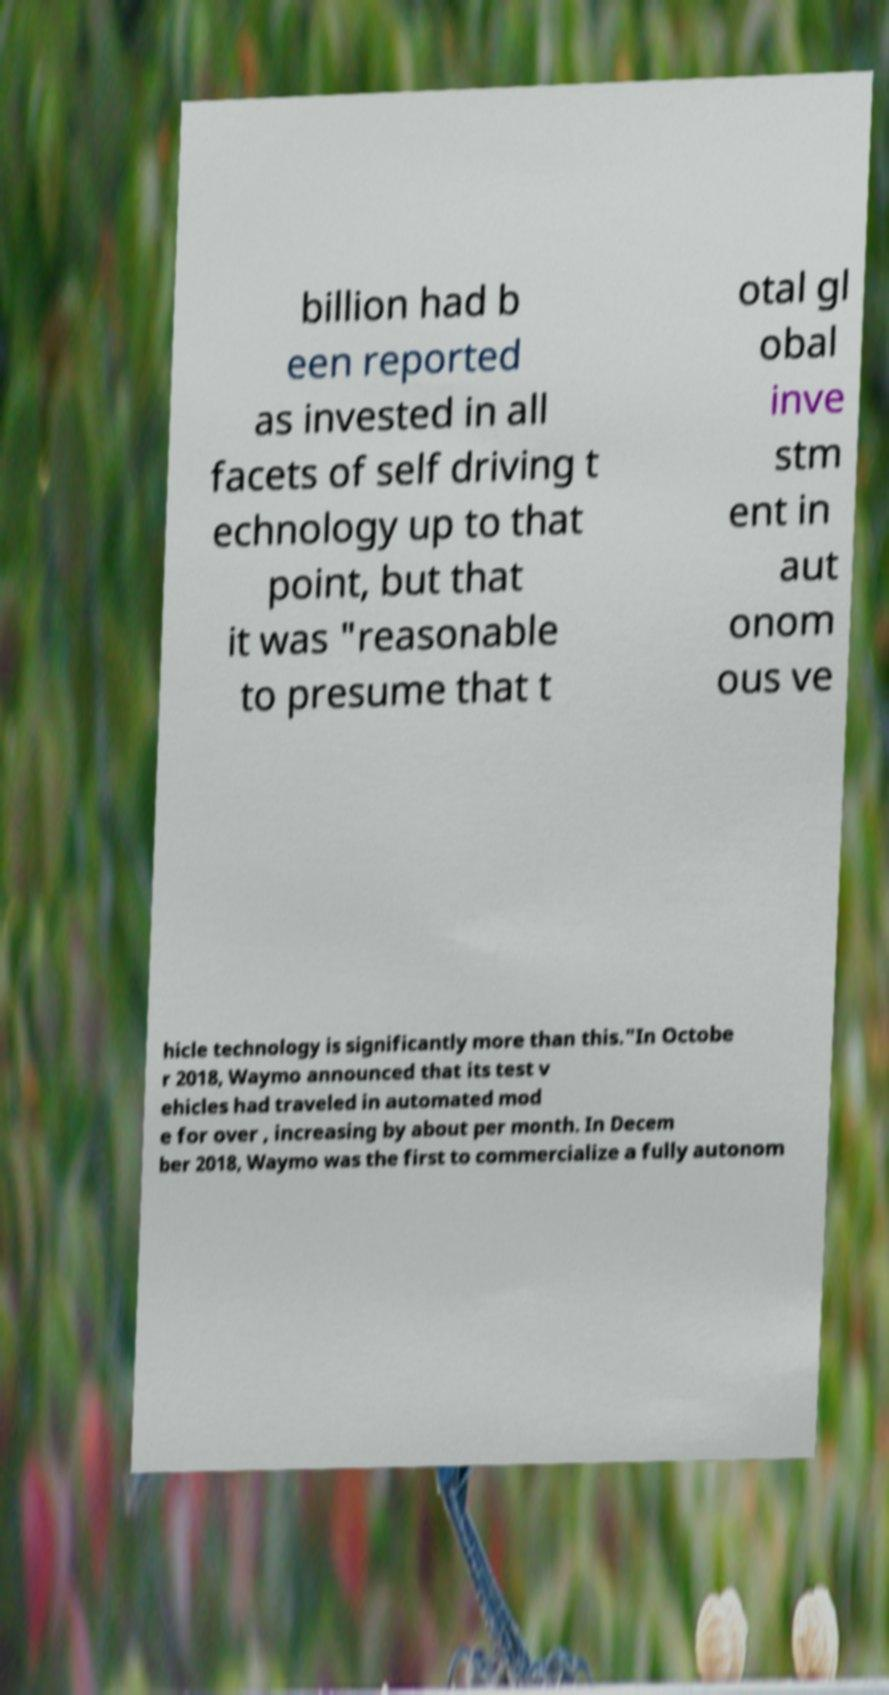There's text embedded in this image that I need extracted. Can you transcribe it verbatim? billion had b een reported as invested in all facets of self driving t echnology up to that point, but that it was "reasonable to presume that t otal gl obal inve stm ent in aut onom ous ve hicle technology is significantly more than this."In Octobe r 2018, Waymo announced that its test v ehicles had traveled in automated mod e for over , increasing by about per month. In Decem ber 2018, Waymo was the first to commercialize a fully autonom 